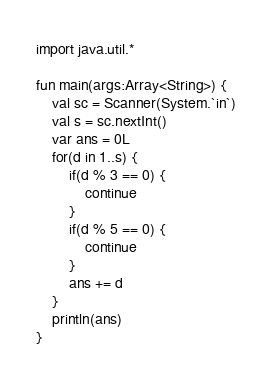Convert code to text. <code><loc_0><loc_0><loc_500><loc_500><_Kotlin_>

import java.util.*

fun main(args:Array<String>) {
    val sc = Scanner(System.`in`)
    val s = sc.nextInt()
    var ans = 0L
    for(d in 1..s) {
        if(d % 3 == 0) {
            continue
        }
        if(d % 5 == 0) {
            continue
        }
        ans += d
    }
    println(ans)
}</code> 